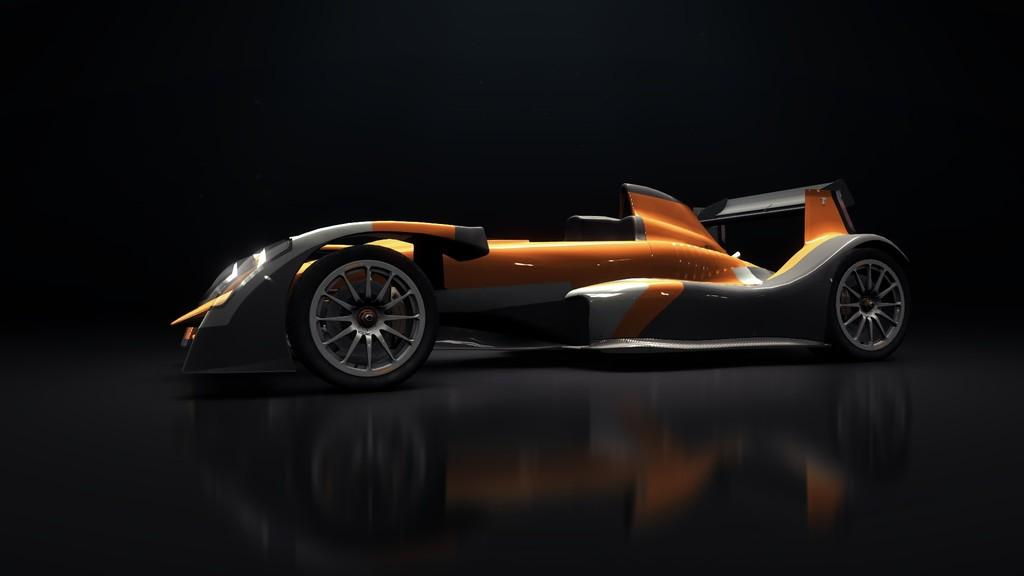What is the main subject in the center of the image? There is a vehicle in the center of the image. What type of vehicle is it? The vehicle appears to be a go-kart. What color is the background of the image? The background of the image is black in color. What does the go-kart taste like in the image? The go-kart is not an edible object, so it does not have a taste. 